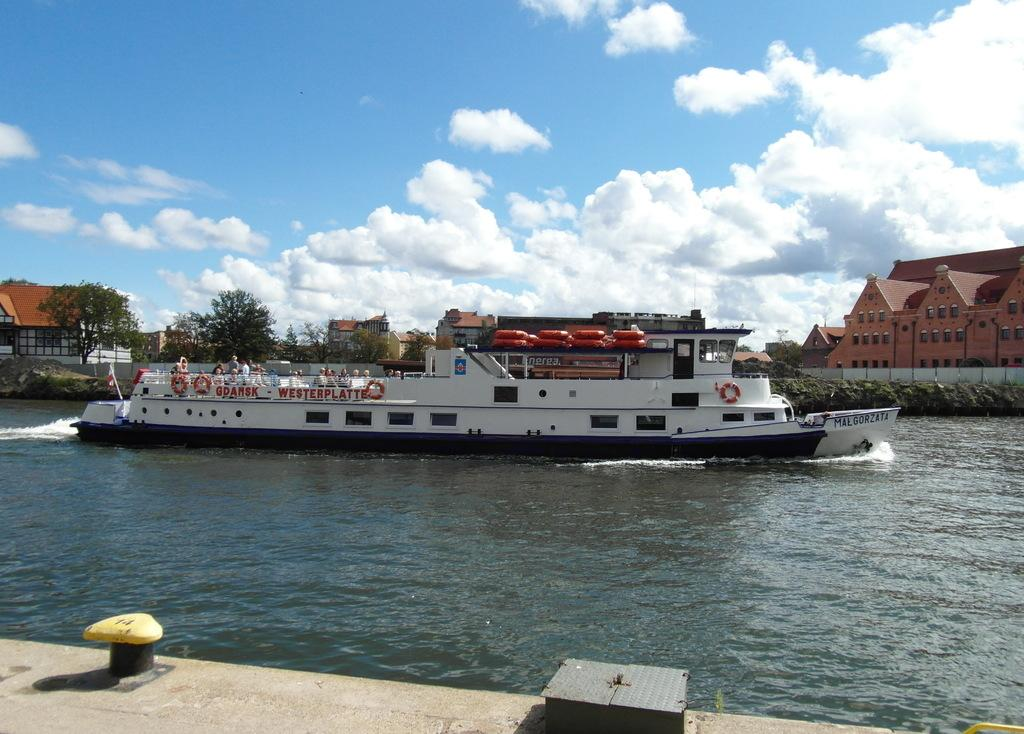What is the main subject of the image? The main subject of the image is a boat. What is happening with the boat in the image? There are people traveling in the boat. Where is the boat located in the image? The boat is on water. What other structures can be seen in the image? There is a building, a fence, and a house in the image. Can you describe the building in the image? The building has windows. What type of vegetation is present in the image? There are trees in the image. What is visible in the sky in the image? The sky is visible in the image, and it looks cloudy. What type of square is being used by the people in the boat to calculate their speed? There is no square or calculator present in the image; the people are simply traveling in the boat. 